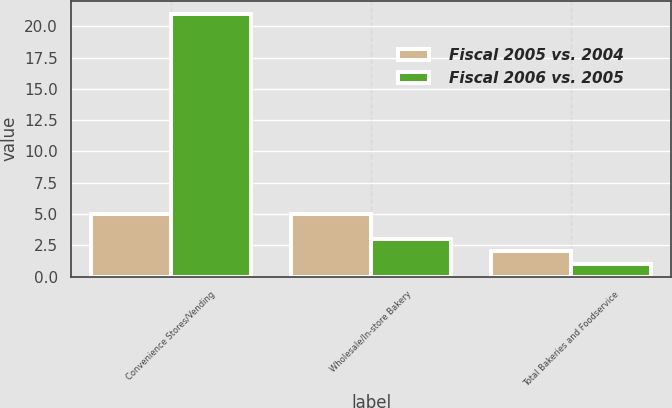Convert chart. <chart><loc_0><loc_0><loc_500><loc_500><stacked_bar_chart><ecel><fcel>Convenience Stores/Vending<fcel>Wholesale/In-store Bakery<fcel>Total Bakeries and Foodservice<nl><fcel>Fiscal 2005 vs. 2004<fcel>5<fcel>5<fcel>2<nl><fcel>Fiscal 2006 vs. 2005<fcel>21<fcel>3<fcel>1<nl></chart> 